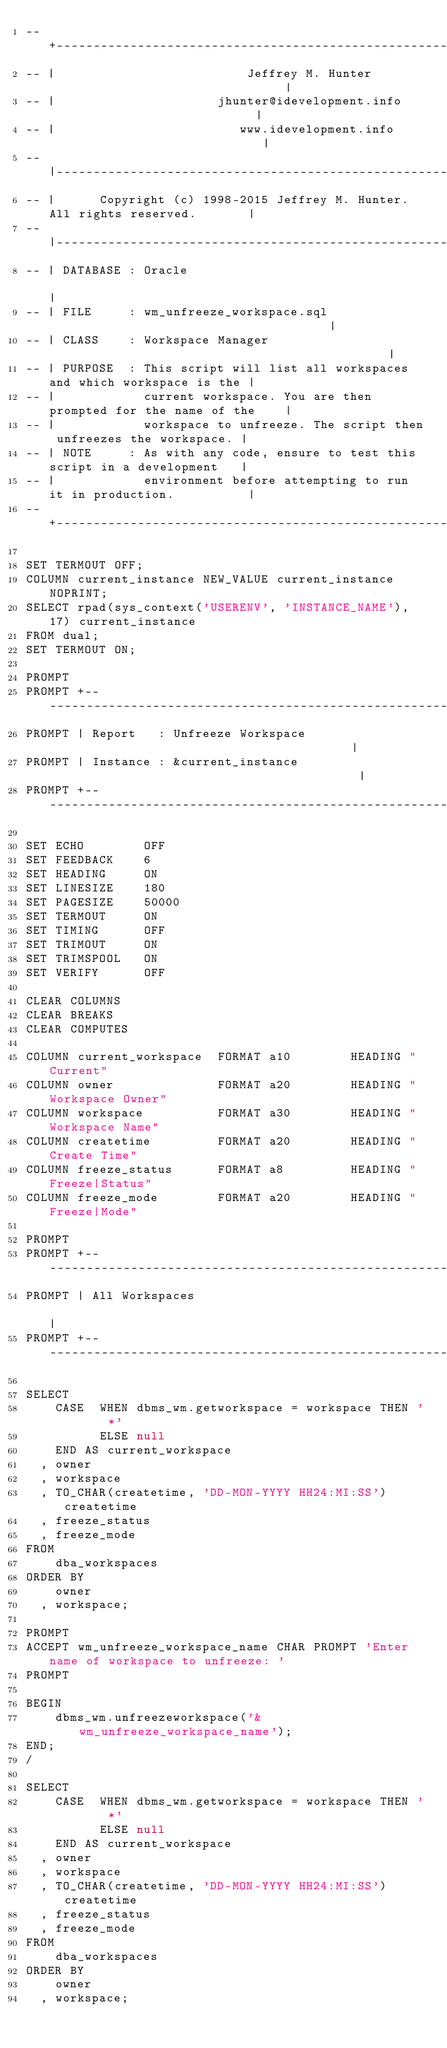<code> <loc_0><loc_0><loc_500><loc_500><_SQL_>-- +----------------------------------------------------------------------------+
-- |                          Jeffrey M. Hunter                                 |
-- |                      jhunter@idevelopment.info                             |
-- |                         www.idevelopment.info                              |
-- |----------------------------------------------------------------------------|
-- |      Copyright (c) 1998-2015 Jeffrey M. Hunter. All rights reserved.       |
-- |----------------------------------------------------------------------------|
-- | DATABASE : Oracle                                                          |
-- | FILE     : wm_unfreeze_workspace.sql                                       |
-- | CLASS    : Workspace Manager                                               |
-- | PURPOSE  : This script will list all workspaces and which workspace is the |
-- |            current workspace. You are then prompted for the name of the    |
-- |            workspace to unfreeze. The script then unfreezes the workspace. |
-- | NOTE     : As with any code, ensure to test this script in a development   |
-- |            environment before attempting to run it in production.          |
-- +----------------------------------------------------------------------------+

SET TERMOUT OFF;
COLUMN current_instance NEW_VALUE current_instance NOPRINT;
SELECT rpad(sys_context('USERENV', 'INSTANCE_NAME'), 17) current_instance
FROM dual;
SET TERMOUT ON;

PROMPT 
PROMPT +------------------------------------------------------------------------+
PROMPT | Report   : Unfreeze Workspace                                          |
PROMPT | Instance : &current_instance                                           |
PROMPT +------------------------------------------------------------------------+

SET ECHO        OFF
SET FEEDBACK    6
SET HEADING     ON
SET LINESIZE    180
SET PAGESIZE    50000
SET TERMOUT     ON
SET TIMING      OFF
SET TRIMOUT     ON
SET TRIMSPOOL   ON
SET VERIFY      OFF

CLEAR COLUMNS
CLEAR BREAKS
CLEAR COMPUTES

COLUMN current_workspace  FORMAT a10        HEADING "Current"
COLUMN owner              FORMAT a20        HEADING "Workspace Owner"
COLUMN workspace          FORMAT a30        HEADING "Workspace Name"
COLUMN createtime         FORMAT a20        HEADING "Create Time"
COLUMN freeze_status      FORMAT a8         HEADING "Freeze|Status"
COLUMN freeze_mode        FORMAT a20        HEADING "Freeze|Mode"

PROMPT 
PROMPT +------------------------------------------------------------------------+
PROMPT | All Workspaces                                                         |
PROMPT +------------------------------------------------------------------------+

SELECT
    CASE  WHEN dbms_wm.getworkspace = workspace THEN '    *'
          ELSE null
    END AS current_workspace
  , owner
  , workspace
  , TO_CHAR(createtime, 'DD-MON-YYYY HH24:MI:SS') createtime
  , freeze_status
  , freeze_mode
FROM
    dba_workspaces
ORDER BY
    owner
  , workspace;

PROMPT 
ACCEPT wm_unfreeze_workspace_name CHAR PROMPT 'Enter name of workspace to unfreeze: '
PROMPT 

BEGIN
    dbms_wm.unfreezeworkspace('&wm_unfreeze_workspace_name');
END;
/

SELECT
    CASE  WHEN dbms_wm.getworkspace = workspace THEN '    *'
          ELSE null
    END AS current_workspace
  , owner
  , workspace
  , TO_CHAR(createtime, 'DD-MON-YYYY HH24:MI:SS') createtime
  , freeze_status
  , freeze_mode
FROM
    dba_workspaces
ORDER BY
    owner
  , workspace;

</code> 